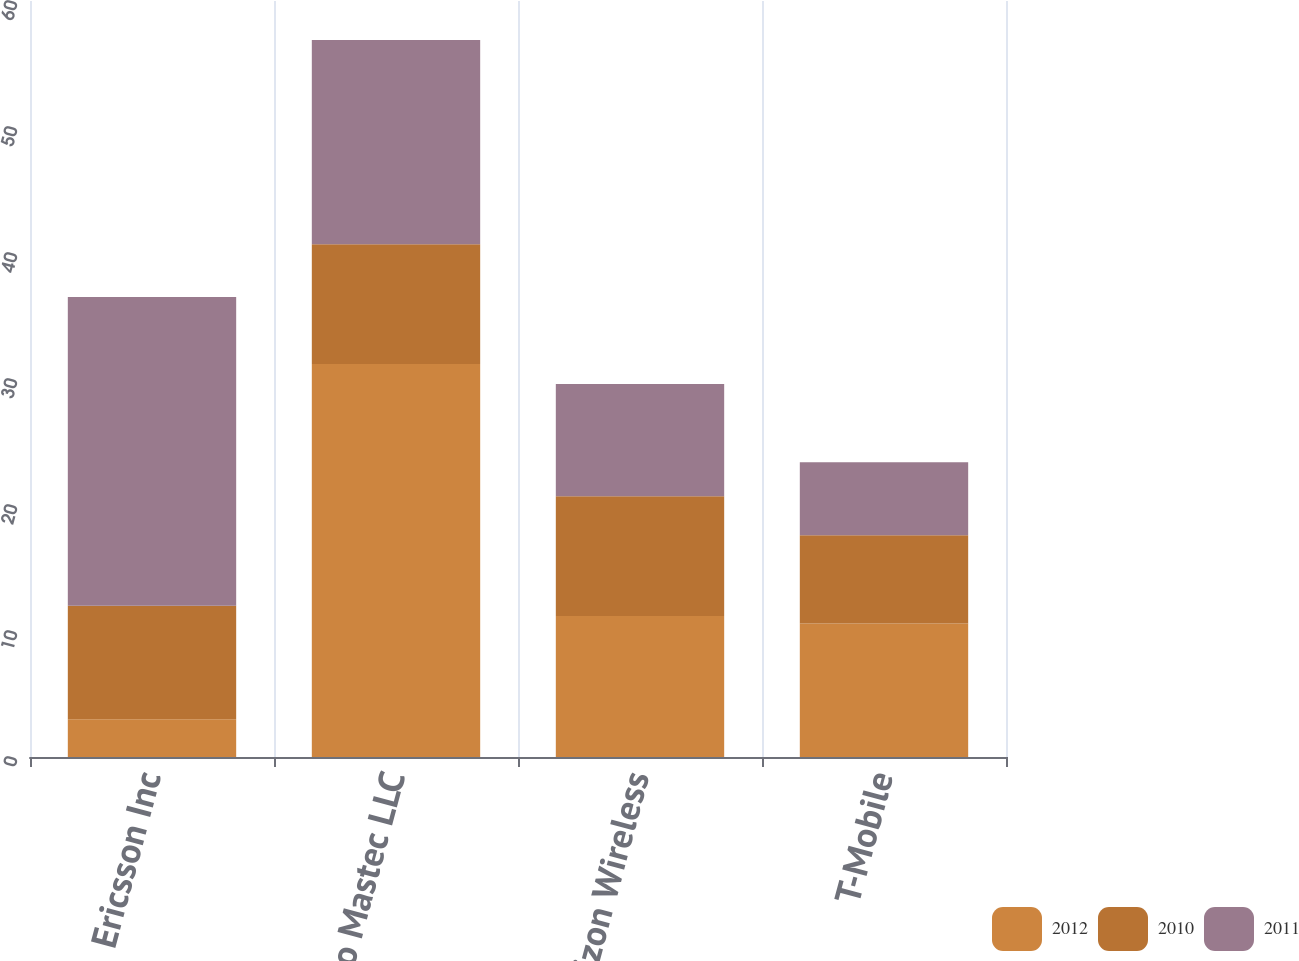Convert chart to OTSL. <chart><loc_0><loc_0><loc_500><loc_500><stacked_bar_chart><ecel><fcel>Ericsson Inc<fcel>Nsoro Mastec LLC<fcel>Verizon Wireless<fcel>T-Mobile<nl><fcel>2012<fcel>3<fcel>31.2<fcel>11.2<fcel>10.6<nl><fcel>2010<fcel>9<fcel>9.5<fcel>9.5<fcel>7<nl><fcel>2011<fcel>24.5<fcel>16.2<fcel>8.9<fcel>5.8<nl></chart> 